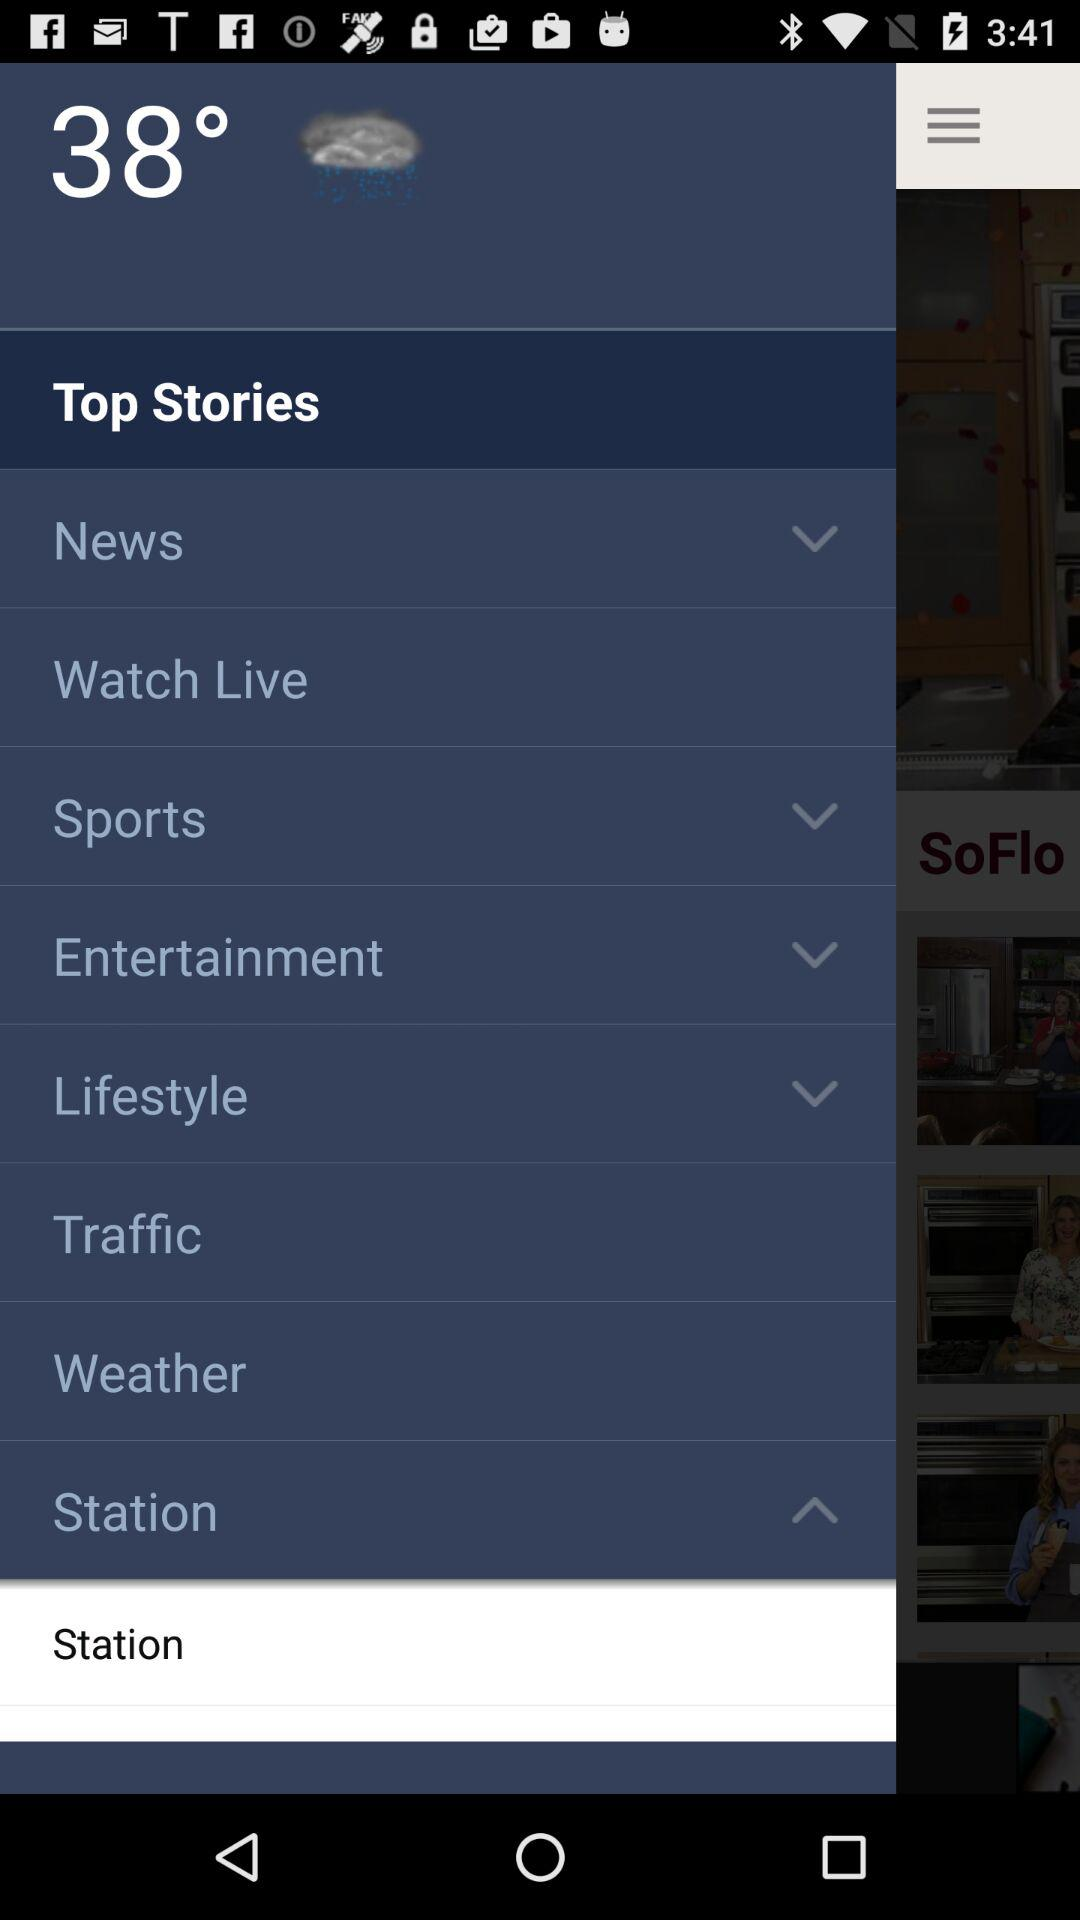How many notifications are there in "Weather"
When the provided information is insufficient, respond with <no answer>. <no answer> 